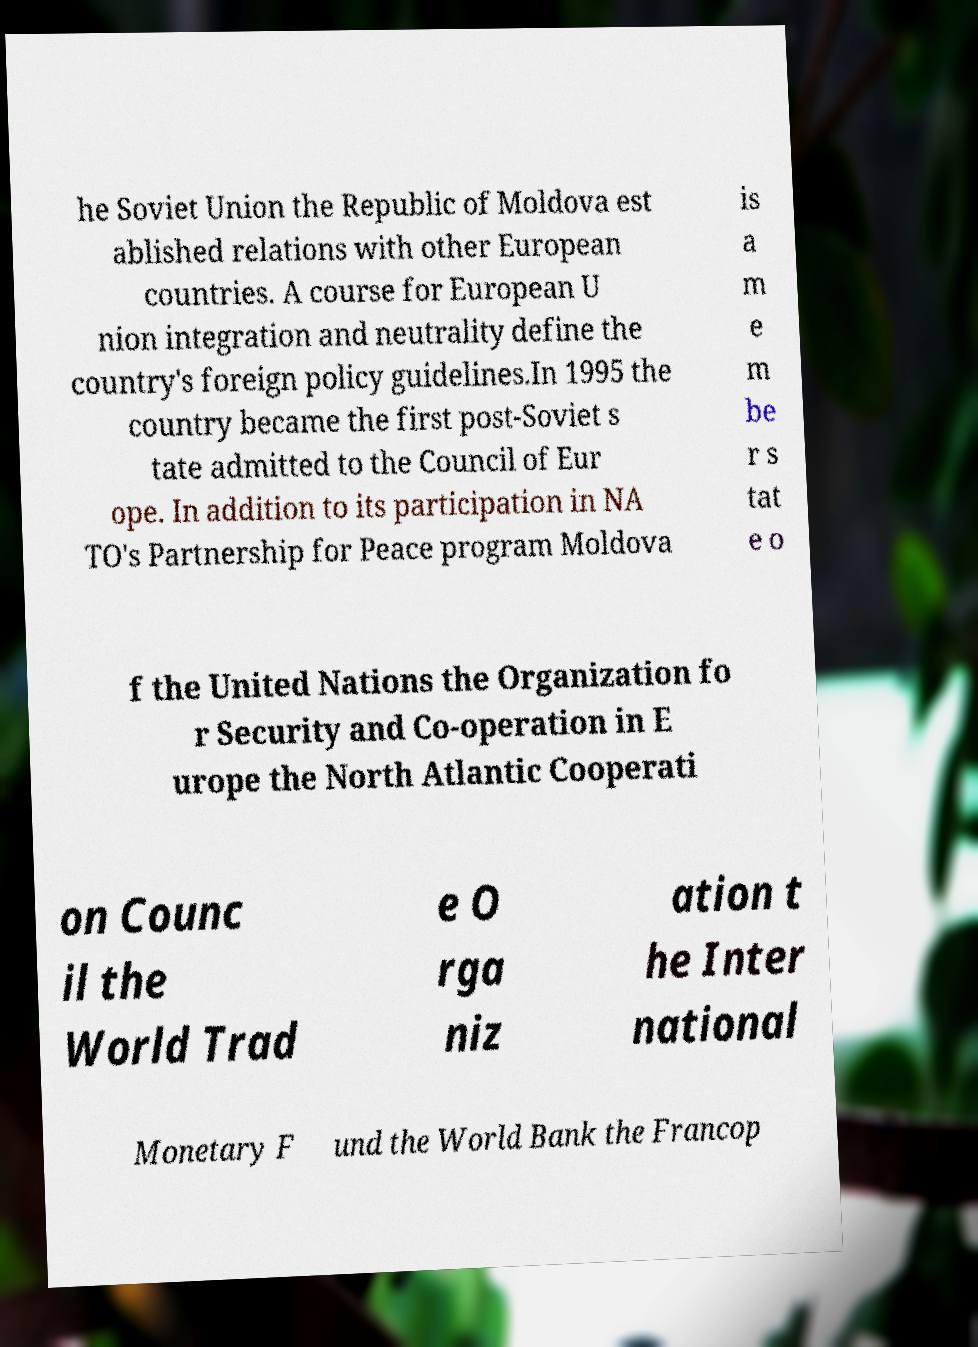Please identify and transcribe the text found in this image. he Soviet Union the Republic of Moldova est ablished relations with other European countries. A course for European U nion integration and neutrality define the country's foreign policy guidelines.In 1995 the country became the first post-Soviet s tate admitted to the Council of Eur ope. In addition to its participation in NA TO's Partnership for Peace program Moldova is a m e m be r s tat e o f the United Nations the Organization fo r Security and Co-operation in E urope the North Atlantic Cooperati on Counc il the World Trad e O rga niz ation t he Inter national Monetary F und the World Bank the Francop 